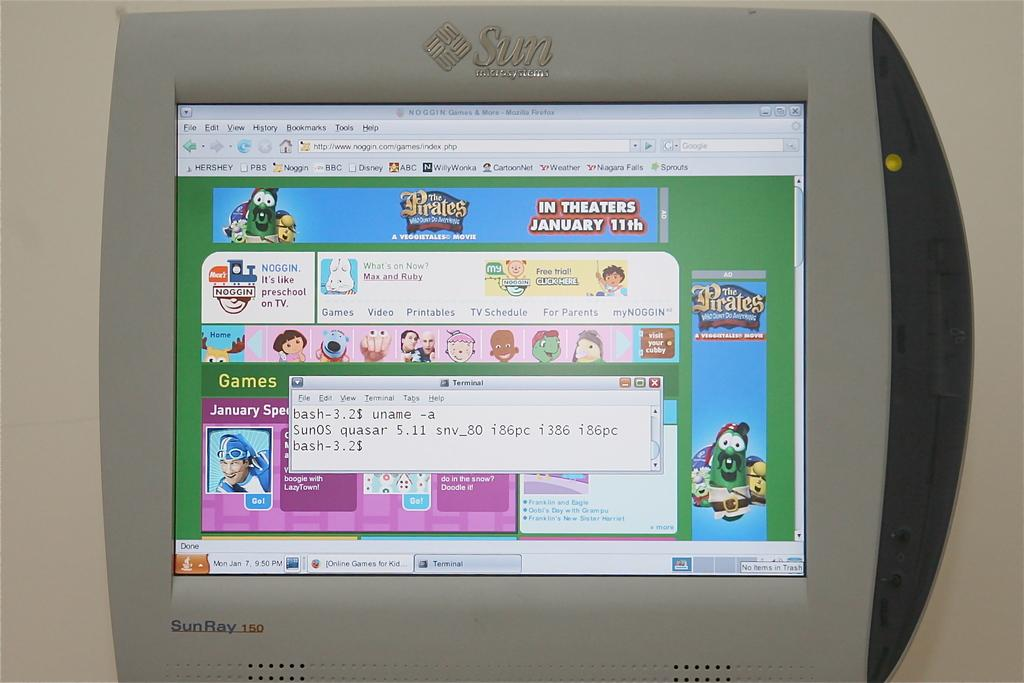<image>
Create a compact narrative representing the image presented. a SUN computer monitor with a colorful website showing 